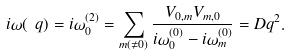<formula> <loc_0><loc_0><loc_500><loc_500>i \omega ( \ q ) = i \omega ^ { ( 2 ) } _ { 0 } = \sum _ { m ( \not = 0 ) } \frac { V _ { 0 , m } V _ { m , 0 } } { i \omega ^ { ( 0 ) } _ { 0 } - i \omega ^ { ( 0 ) } _ { m } } = D q ^ { 2 } .</formula> 